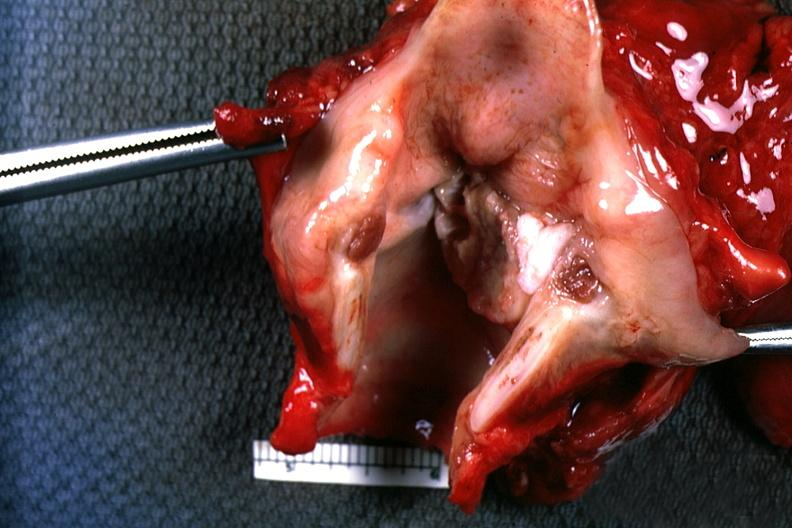s larynx present?
Answer the question using a single word or phrase. Yes 